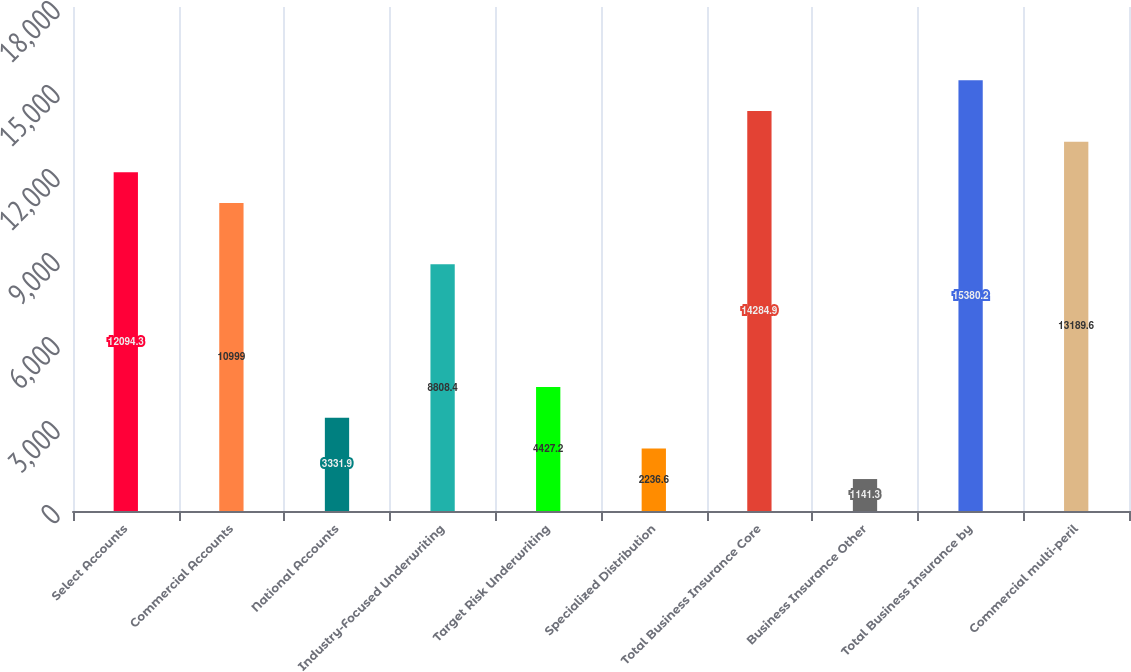<chart> <loc_0><loc_0><loc_500><loc_500><bar_chart><fcel>Select Accounts<fcel>Commercial Accounts<fcel>National Accounts<fcel>Industry-Focused Underwriting<fcel>Target Risk Underwriting<fcel>Specialized Distribution<fcel>Total Business Insurance Core<fcel>Business Insurance Other<fcel>Total Business Insurance by<fcel>Commercial multi-peril<nl><fcel>12094.3<fcel>10999<fcel>3331.9<fcel>8808.4<fcel>4427.2<fcel>2236.6<fcel>14284.9<fcel>1141.3<fcel>15380.2<fcel>13189.6<nl></chart> 